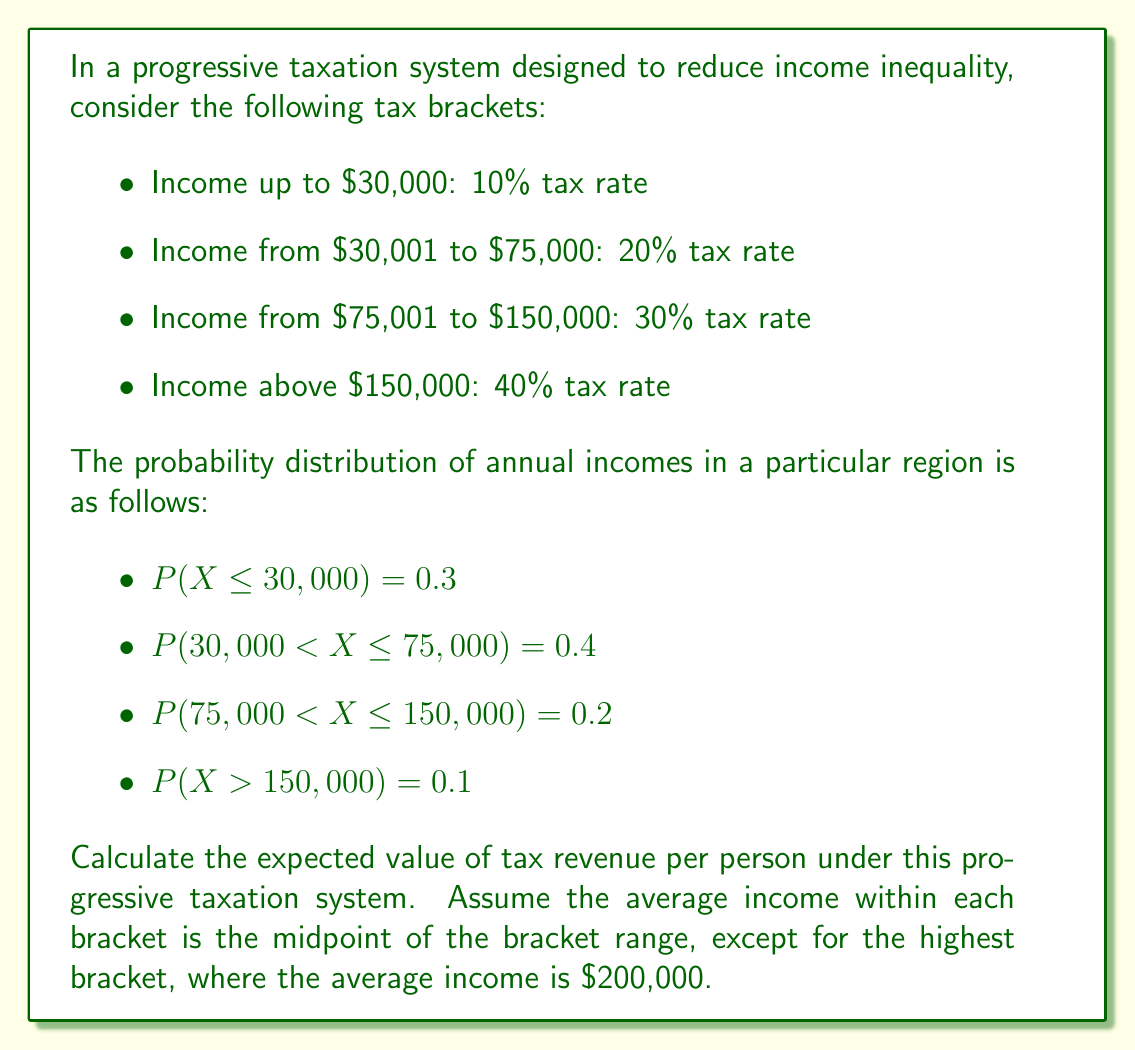What is the answer to this math problem? To calculate the expected value of tax revenue per person, we need to:

1. Determine the average income and tax amount for each bracket
2. Calculate the probability-weighted tax amount for each bracket
3. Sum the weighted tax amounts

Let's go through each step:

1. Average income and tax amount for each bracket:

   a) $0 - $30,000:
      Average income = $15,000
      Tax = $15,000 \times 0.10 = $1,500

   b) $30,001 - $75,000:
      Average income = $52,500
      Tax = $30,000 \times 0.10 + ($52,500 - $30,000) \times 0.20 = $3,000 + $4,500 = $7,500

   c) $75,001 - $150,000:
      Average income = $112,500
      Tax = $30,000 \times 0.10 + ($75,000 - $30,000) \times 0.20 + ($112,500 - $75,000) \times 0.30
         = $3,000 + $9,000 + $11,250 = $23,250

   d) Above $150,000:
      Average income = $200,000
      Tax = $30,000 \times 0.10 + ($75,000 - $30,000) \times 0.20 + ($150,000 - $75,000) \times 0.30 + ($200,000 - $150,000) \times 0.40
         = $3,000 + $9,000 + $22,500 + $20,000 = $54,500

2. Probability-weighted tax amount for each bracket:

   a) $0 - $30,000: $1,500 \times 0.3 = $450
   b) $30,001 - $75,000: $7,500 \times 0.4 = $3,000
   c) $75,001 - $150,000: $23,250 \times 0.2 = $4,650
   d) Above $150,000: $54,500 \times 0.1 = $5,450

3. Sum of weighted tax amounts:

   Expected value = $450 + $3,000 + $4,650 + $5,450 = $13,550

Therefore, the expected value of tax revenue per person under this progressive taxation system is $13,550.
Answer: $13,550 